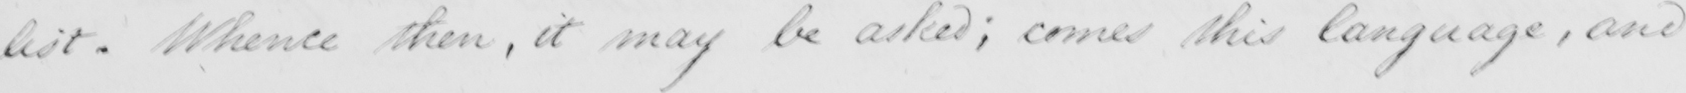What does this handwritten line say? list . Whence then , it may be asked ; comes this language , and 